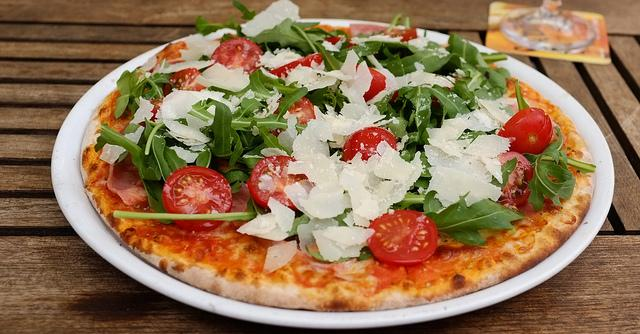Why would someone sit at this table? Please explain your reasoning. to eat. If they wanted to eat they would sit down. 